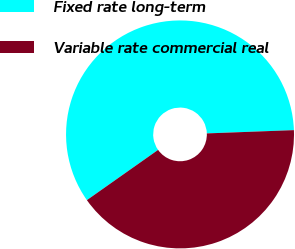<chart> <loc_0><loc_0><loc_500><loc_500><pie_chart><fcel>Fixed rate long-term<fcel>Variable rate commercial real<nl><fcel>59.18%<fcel>40.82%<nl></chart> 